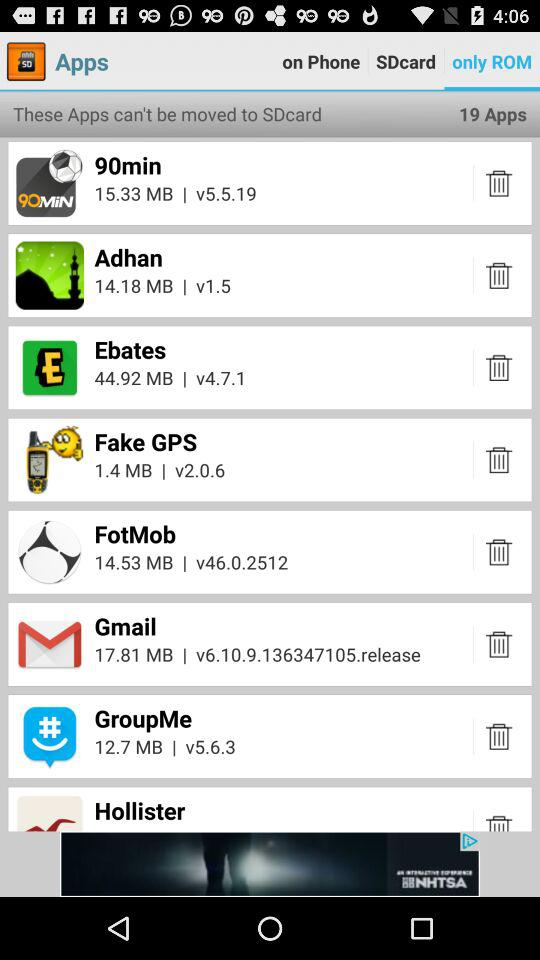How many apps are unable to be moved to SDcard?
Answer the question using a single word or phrase. 19 